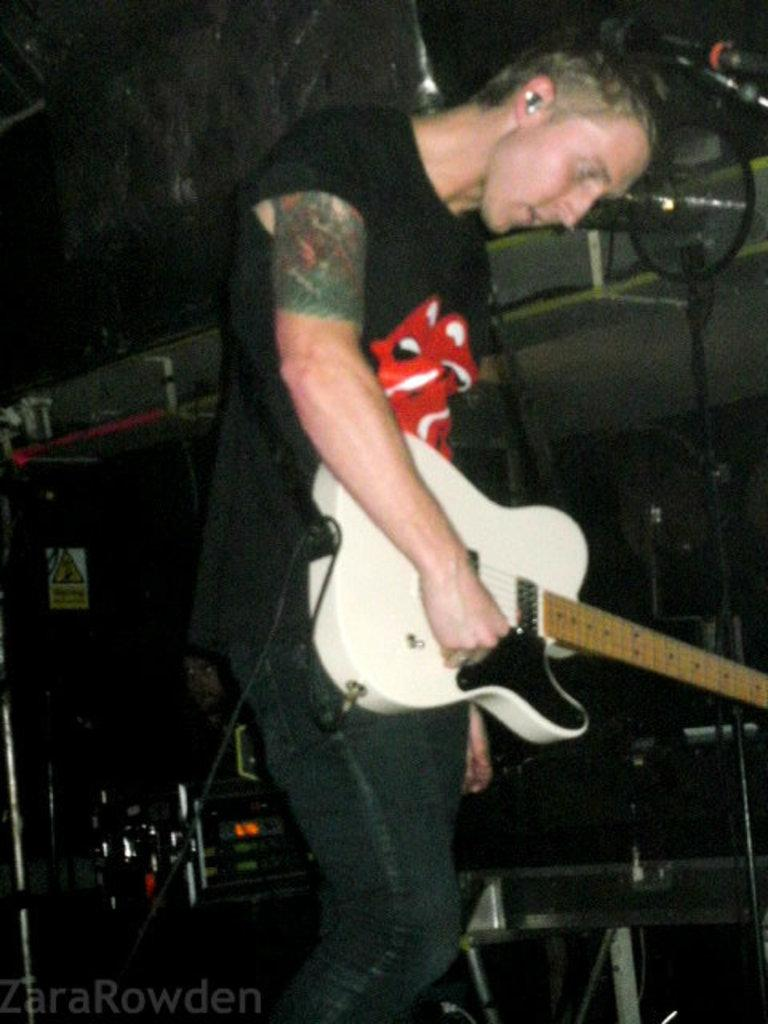What is the main subject of the image? The main subject of the image is a man. What is the man doing in the image? The man is standing in the image. What object is the man holding in the image? The man is holding a guitar in the image. What other object can be seen in the image? There is a microphone in the image. How much wealth does the flower in the image possess? There is no flower present in the image, so it is not possible to determine its wealth. 